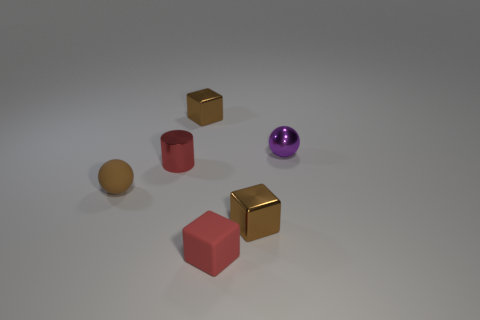How many brown cubes must be subtracted to get 1 brown cubes? 1 Subtract all brown cubes. How many cubes are left? 1 Add 2 brown spheres. How many objects exist? 8 Subtract all cylinders. How many objects are left? 5 Subtract 1 blocks. How many blocks are left? 2 Subtract all red cubes. How many cubes are left? 2 Subtract 0 gray cylinders. How many objects are left? 6 Subtract all yellow cubes. Subtract all cyan balls. How many cubes are left? 3 Subtract all red blocks. How many purple spheres are left? 1 Subtract all tiny red matte objects. Subtract all tiny rubber things. How many objects are left? 3 